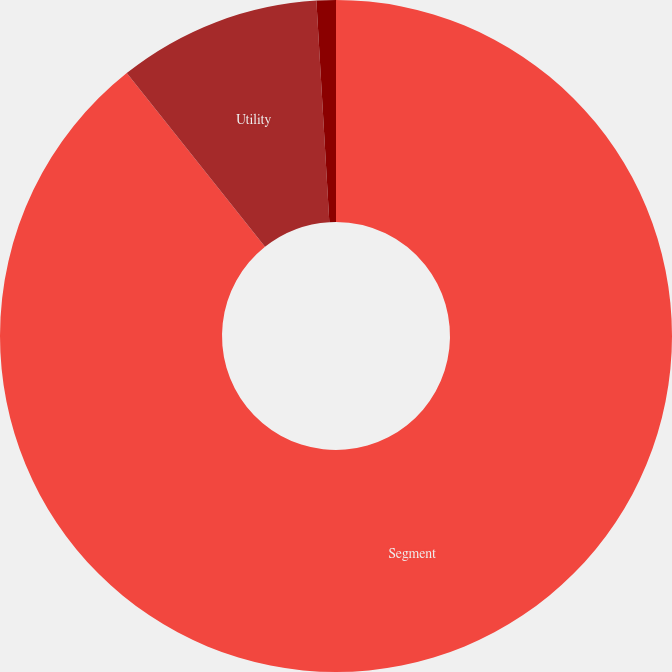<chart> <loc_0><loc_0><loc_500><loc_500><pie_chart><fcel>Segment<fcel>Utility<fcel>Entergy Wholesale Commodities<nl><fcel>89.3%<fcel>9.77%<fcel>0.93%<nl></chart> 